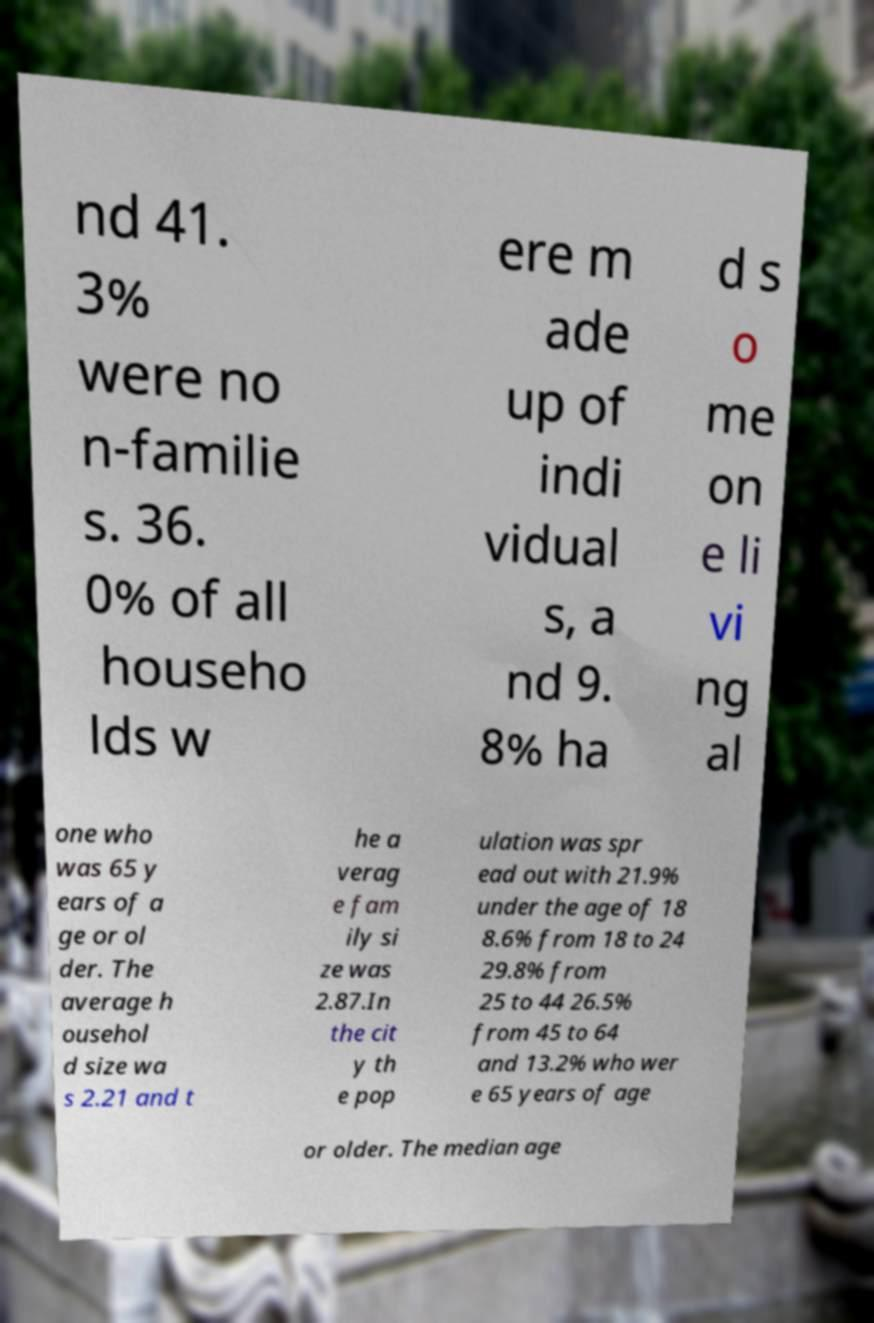What messages or text are displayed in this image? I need them in a readable, typed format. nd 41. 3% were no n-familie s. 36. 0% of all househo lds w ere m ade up of indi vidual s, a nd 9. 8% ha d s o me on e li vi ng al one who was 65 y ears of a ge or ol der. The average h ousehol d size wa s 2.21 and t he a verag e fam ily si ze was 2.87.In the cit y th e pop ulation was spr ead out with 21.9% under the age of 18 8.6% from 18 to 24 29.8% from 25 to 44 26.5% from 45 to 64 and 13.2% who wer e 65 years of age or older. The median age 